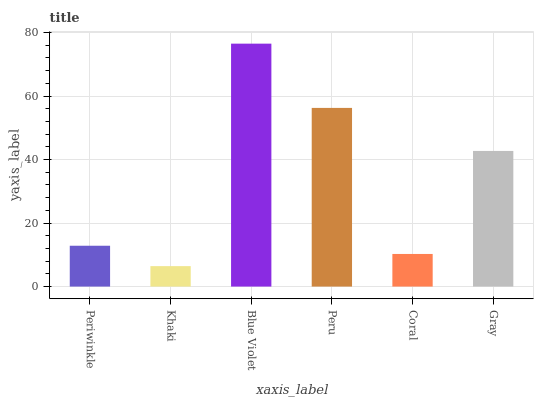Is Khaki the minimum?
Answer yes or no. Yes. Is Blue Violet the maximum?
Answer yes or no. Yes. Is Blue Violet the minimum?
Answer yes or no. No. Is Khaki the maximum?
Answer yes or no. No. Is Blue Violet greater than Khaki?
Answer yes or no. Yes. Is Khaki less than Blue Violet?
Answer yes or no. Yes. Is Khaki greater than Blue Violet?
Answer yes or no. No. Is Blue Violet less than Khaki?
Answer yes or no. No. Is Gray the high median?
Answer yes or no. Yes. Is Periwinkle the low median?
Answer yes or no. Yes. Is Peru the high median?
Answer yes or no. No. Is Coral the low median?
Answer yes or no. No. 